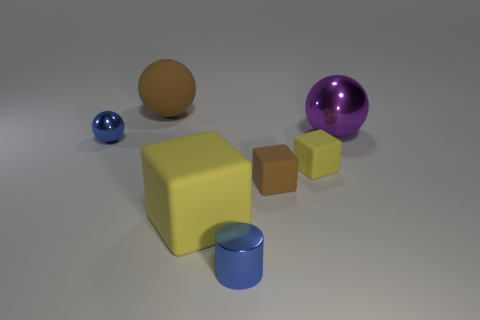Are any tiny green matte objects visible?
Make the answer very short. No. What is the material of the cylinder that is the same color as the tiny ball?
Offer a very short reply. Metal. What number of things are blue metallic cylinders or big purple metallic spheres?
Your answer should be very brief. 2. Are there any objects of the same color as the rubber ball?
Offer a terse response. Yes. How many yellow things are on the right side of the small blue metal object behind the tiny brown rubber object?
Provide a short and direct response. 2. Are there more tiny rubber cubes than tiny cyan matte cubes?
Provide a succinct answer. Yes. Are the big brown sphere and the purple thing made of the same material?
Offer a very short reply. No. Are there an equal number of cubes on the left side of the large yellow matte object and purple metallic objects?
Your answer should be compact. No. What number of purple objects are made of the same material as the large brown object?
Offer a terse response. 0. Are there fewer gray metal balls than brown spheres?
Provide a short and direct response. Yes. 